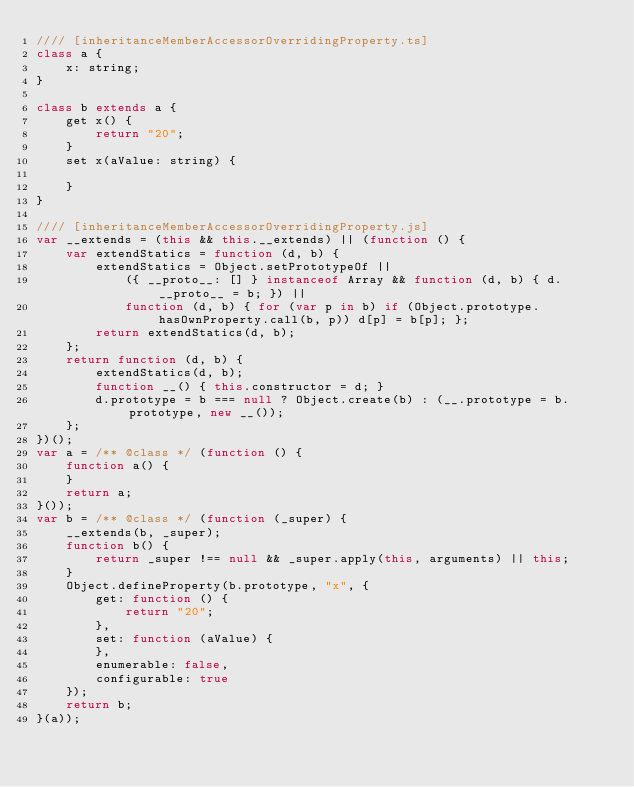<code> <loc_0><loc_0><loc_500><loc_500><_JavaScript_>//// [inheritanceMemberAccessorOverridingProperty.ts]
class a {
    x: string;
}

class b extends a {
    get x() {
        return "20";
    }
    set x(aValue: string) {

    }
}

//// [inheritanceMemberAccessorOverridingProperty.js]
var __extends = (this && this.__extends) || (function () {
    var extendStatics = function (d, b) {
        extendStatics = Object.setPrototypeOf ||
            ({ __proto__: [] } instanceof Array && function (d, b) { d.__proto__ = b; }) ||
            function (d, b) { for (var p in b) if (Object.prototype.hasOwnProperty.call(b, p)) d[p] = b[p]; };
        return extendStatics(d, b);
    };
    return function (d, b) {
        extendStatics(d, b);
        function __() { this.constructor = d; }
        d.prototype = b === null ? Object.create(b) : (__.prototype = b.prototype, new __());
    };
})();
var a = /** @class */ (function () {
    function a() {
    }
    return a;
}());
var b = /** @class */ (function (_super) {
    __extends(b, _super);
    function b() {
        return _super !== null && _super.apply(this, arguments) || this;
    }
    Object.defineProperty(b.prototype, "x", {
        get: function () {
            return "20";
        },
        set: function (aValue) {
        },
        enumerable: false,
        configurable: true
    });
    return b;
}(a));
</code> 